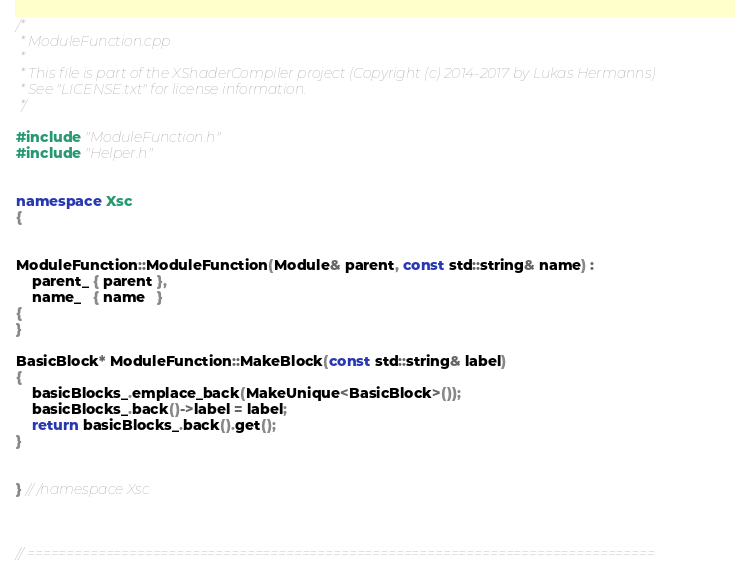<code> <loc_0><loc_0><loc_500><loc_500><_C++_>/*
 * ModuleFunction.cpp
 * 
 * This file is part of the XShaderCompiler project (Copyright (c) 2014-2017 by Lukas Hermanns)
 * See "LICENSE.txt" for license information.
 */

#include "ModuleFunction.h"
#include "Helper.h"


namespace Xsc
{


ModuleFunction::ModuleFunction(Module& parent, const std::string& name) :
    parent_ { parent },
    name_   { name   }
{
}

BasicBlock* ModuleFunction::MakeBlock(const std::string& label)
{
    basicBlocks_.emplace_back(MakeUnique<BasicBlock>());
    basicBlocks_.back()->label = label;
    return basicBlocks_.back().get();
}


} // /namespace Xsc



// ================================================================================
</code> 